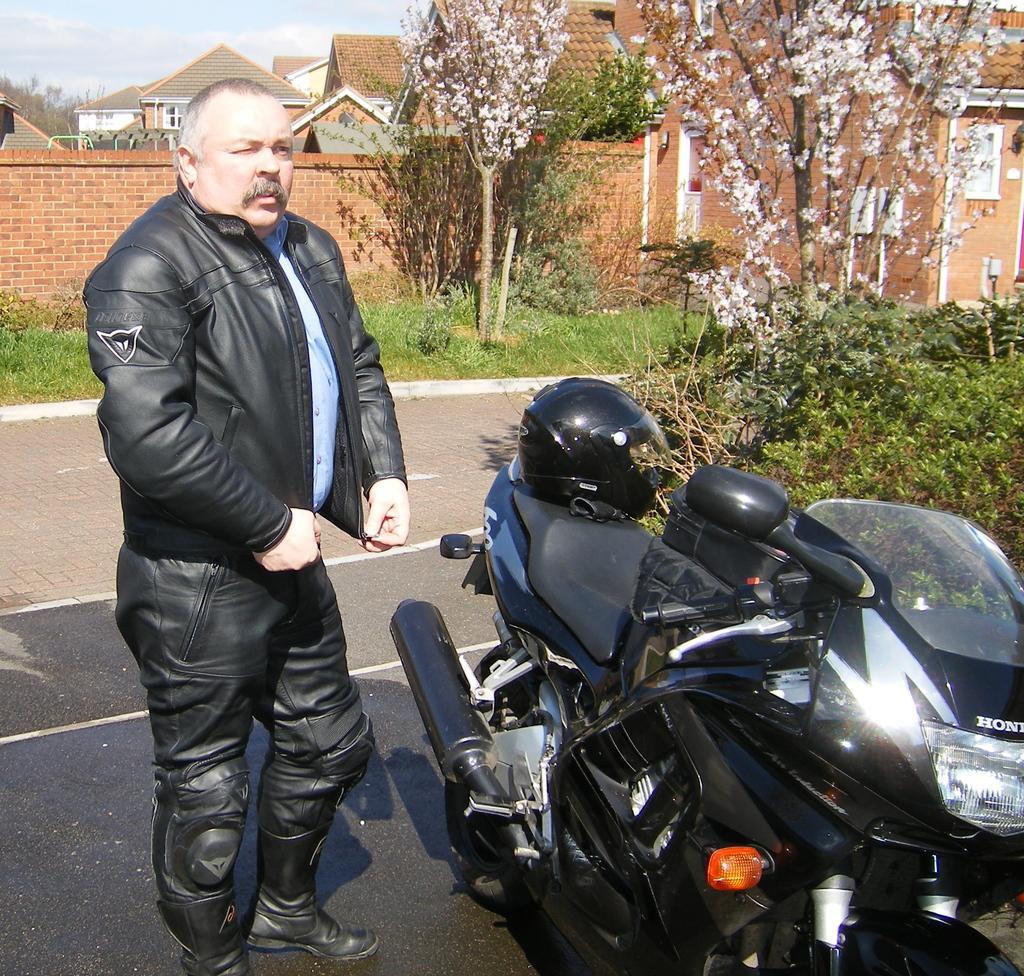Could you give a brief overview of what you see in this image? On the left side of this image I can see a man wearing black color jacket, standing on the road. In front of this man there is a bike. On both sides of the road, I can see the grass and the plants. In the background there are some trees and the houses. At the top I can see the sky. 